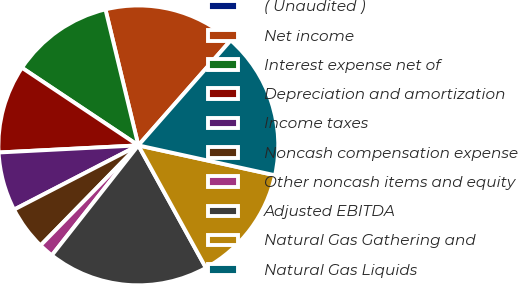Convert chart. <chart><loc_0><loc_0><loc_500><loc_500><pie_chart><fcel>( Unaudited )<fcel>Net income<fcel>Interest expense net of<fcel>Depreciation and amortization<fcel>Income taxes<fcel>Noncash compensation expense<fcel>Other noncash items and equity<fcel>Adjusted EBITDA<fcel>Natural Gas Gathering and<fcel>Natural Gas Liquids<nl><fcel>0.01%<fcel>15.25%<fcel>11.86%<fcel>10.17%<fcel>6.78%<fcel>5.09%<fcel>1.71%<fcel>18.63%<fcel>13.55%<fcel>16.94%<nl></chart> 